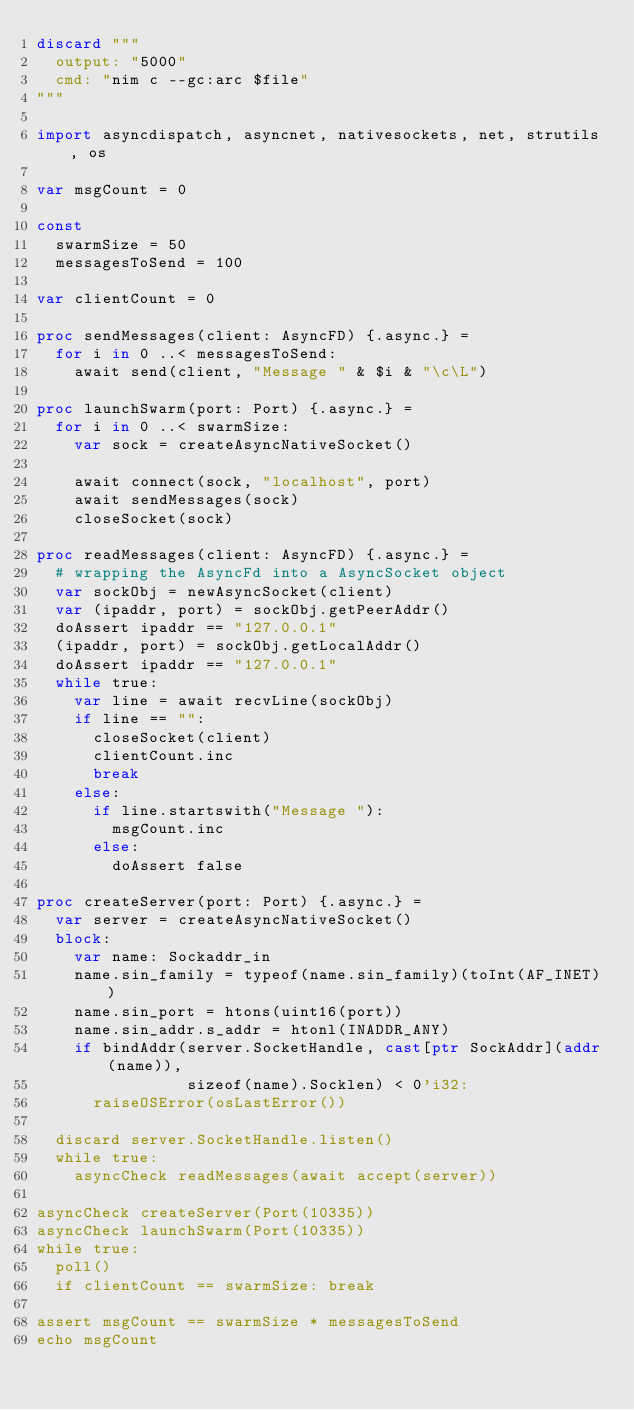Convert code to text. <code><loc_0><loc_0><loc_500><loc_500><_Nim_>discard """
  output: "5000"
  cmd: "nim c --gc:arc $file"
"""

import asyncdispatch, asyncnet, nativesockets, net, strutils, os

var msgCount = 0

const
  swarmSize = 50
  messagesToSend = 100

var clientCount = 0

proc sendMessages(client: AsyncFD) {.async.} =
  for i in 0 ..< messagesToSend:
    await send(client, "Message " & $i & "\c\L")

proc launchSwarm(port: Port) {.async.} =
  for i in 0 ..< swarmSize:
    var sock = createAsyncNativeSocket()

    await connect(sock, "localhost", port)
    await sendMessages(sock)
    closeSocket(sock)

proc readMessages(client: AsyncFD) {.async.} =
  # wrapping the AsyncFd into a AsyncSocket object
  var sockObj = newAsyncSocket(client)
  var (ipaddr, port) = sockObj.getPeerAddr()
  doAssert ipaddr == "127.0.0.1"
  (ipaddr, port) = sockObj.getLocalAddr()
  doAssert ipaddr == "127.0.0.1"
  while true:
    var line = await recvLine(sockObj)
    if line == "":
      closeSocket(client)
      clientCount.inc
      break
    else:
      if line.startswith("Message "):
        msgCount.inc
      else:
        doAssert false

proc createServer(port: Port) {.async.} =
  var server = createAsyncNativeSocket()
  block:
    var name: Sockaddr_in
    name.sin_family = typeof(name.sin_family)(toInt(AF_INET))
    name.sin_port = htons(uint16(port))
    name.sin_addr.s_addr = htonl(INADDR_ANY)
    if bindAddr(server.SocketHandle, cast[ptr SockAddr](addr(name)),
                sizeof(name).Socklen) < 0'i32:
      raiseOSError(osLastError())

  discard server.SocketHandle.listen()
  while true:
    asyncCheck readMessages(await accept(server))

asyncCheck createServer(Port(10335))
asyncCheck launchSwarm(Port(10335))
while true:
  poll()
  if clientCount == swarmSize: break

assert msgCount == swarmSize * messagesToSend
echo msgCount
</code> 